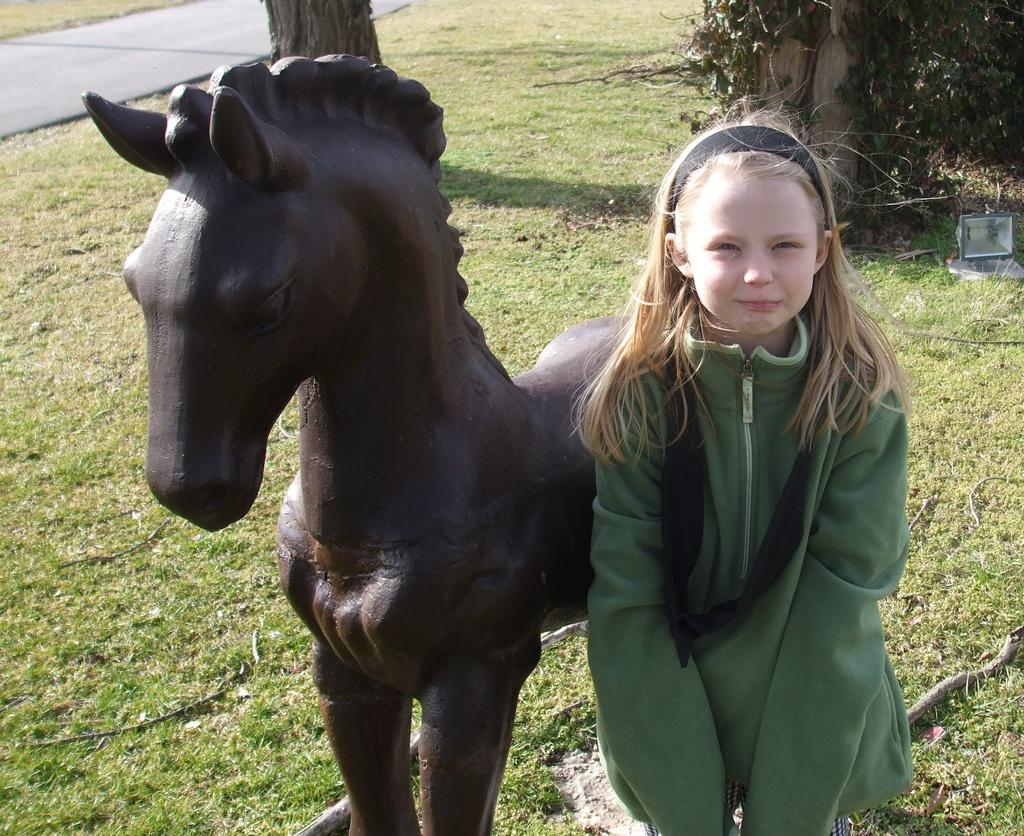What is the main subject in the center of the image? There is a horse statue and a girl in the center of the image. What type of vegetation can be seen in the background of the image? There is grass and trees in the background of the image. What else is visible in the background of the image? There is a road in the background of the image. What type of trade is being conducted by the monkey in the image? There is no monkey present in the image, so no trade can be observed. 